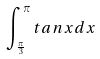Convert formula to latex. <formula><loc_0><loc_0><loc_500><loc_500>\int _ { \frac { \pi } { 3 } } ^ { \pi } t a n x d x</formula> 